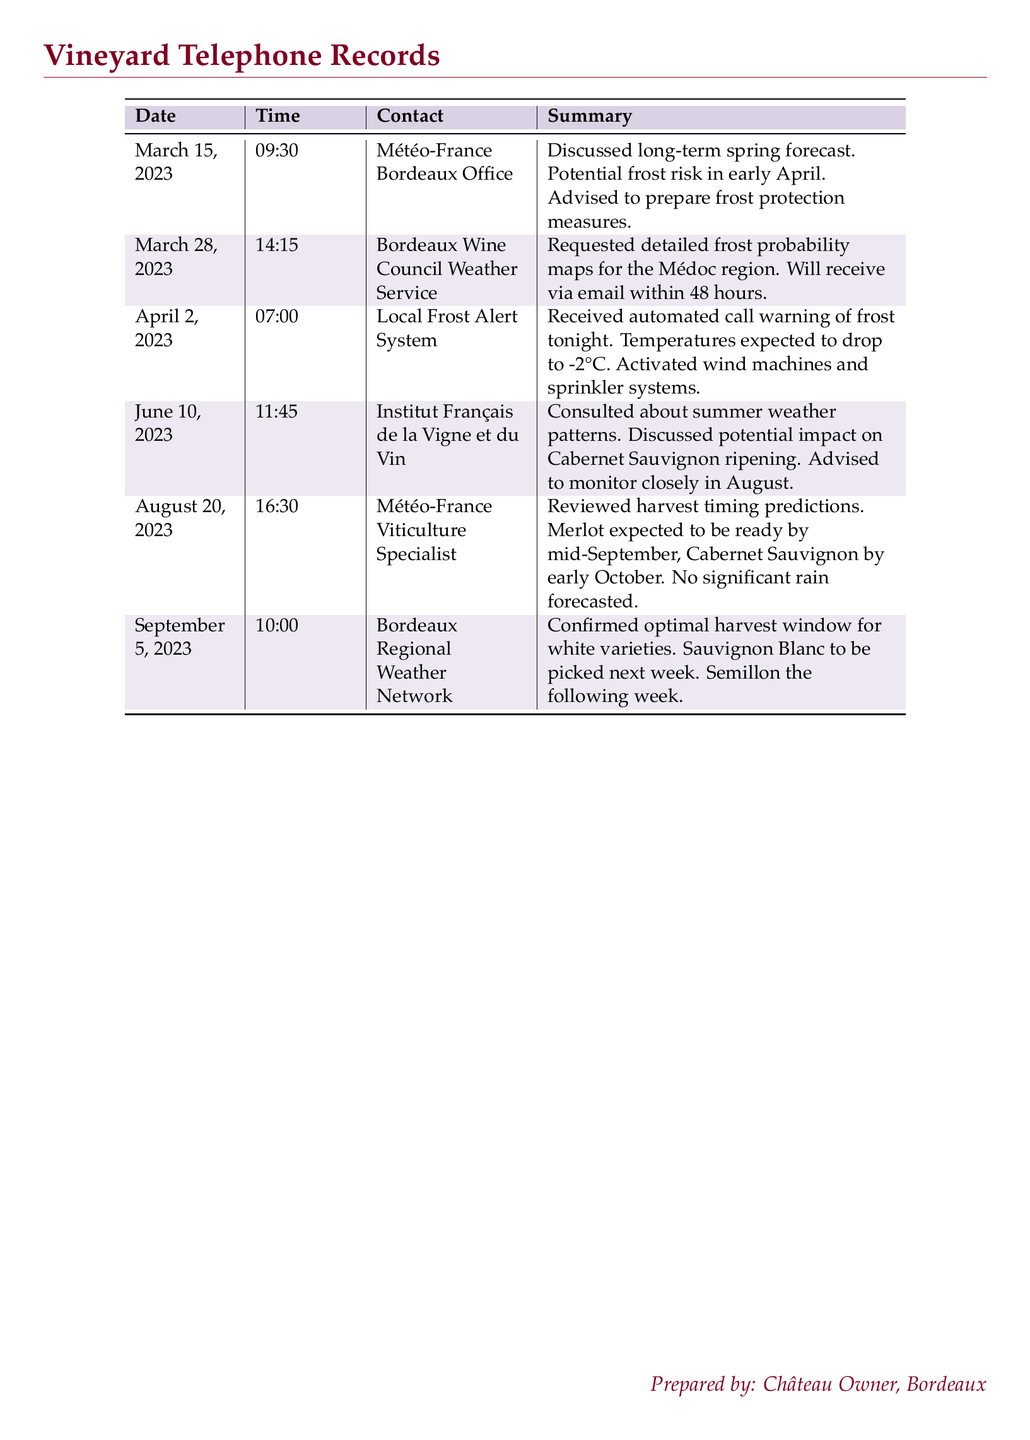What date was the frost risk discussed? The frost risk was discussed on March 15, 2023, in a call with Météo-France Bordeaux Office.
Answer: March 15, 2023 What temperature was expected during the frost alert on April 2? The automated call warned that temperatures were expected to drop to -2°C during the frost alert.
Answer: -2°C Which grape variety is expected to be ready for harvest by mid-September? The document states that Merlot is expected to be ready for harvest by mid-September.
Answer: Merlot What service provided detailed frost probability maps? The Bordeaux Wine Council Weather Service was contacted for detailed frost probability maps for the Médoc region.
Answer: Bordeaux Wine Council Weather Service How long did the Bordeaux Wine Council say it would take to receive the frost maps? The frost probability maps were promised to be received via email within 48 hours.
Answer: 48 hours What was the purpose of the call on June 10, 2023? The call on June 10, 2023, was to consult about summer weather patterns and the impact on Cabernet Sauvignon ripening.
Answer: Summer weather patterns Which varieties' harvests were confirmed by the Bordeaux Regional Weather Network? The confirmed harvests for white varieties were Sauvignon Blanc and Semillon.
Answer: Sauvignon Blanc and Semillon Who prepared the document? The document was prepared by the Château Owner, Bordeaux.
Answer: Château Owner 